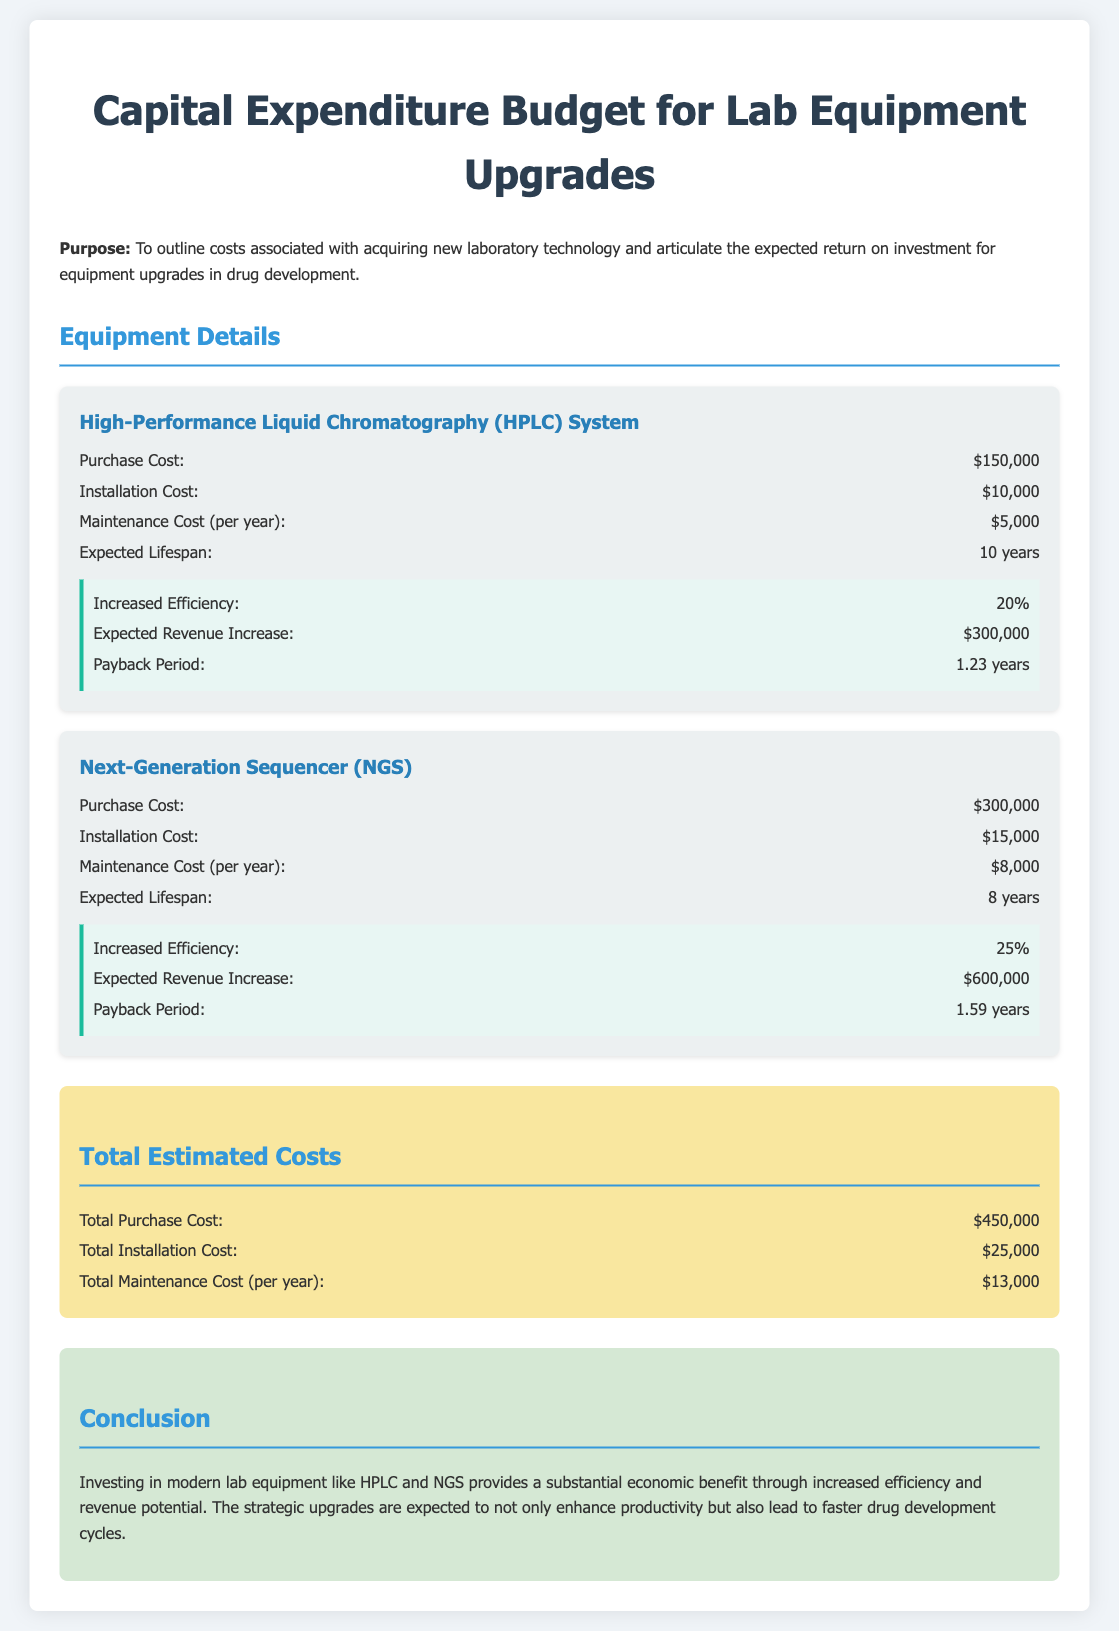What is the purchase cost of the HPLC system? The purchase cost is specifically stated in the document for the HPLC system, which is $150,000.
Answer: $150,000 What is the expected lifespan of the NGS? The expected lifespan of the NGS is mentioned in the document as 8 years.
Answer: 8 years What is the installation cost for both equipment? The total installation cost is calculated from the individual installation costs of HPLC and NGS, which are $10,000 and $15,000 respectively, summing to $25,000.
Answer: $25,000 What is the annual maintenance cost for the HPLC system? The document specifies that the annual maintenance cost for the HPLC system is $5,000.
Answer: $5,000 What is the expected revenue increase from the NGS? The document states the expected revenue increase from the NGS as $600,000.
Answer: $600,000 What is the payback period for the HPLC system? The payback period for the HPLC system is clearly indicated in the document as 1.23 years.
Answer: 1.23 years What percentage increase in efficiency does the NGS provide? The document indicates that the NGS provides an increased efficiency of 25%.
Answer: 25% What is the total estimated maintenance cost per year? The total estimated maintenance cost per year is found by summing the individual maintenance costs from both systems, which totals $13,000.
Answer: $13,000 What is the main conclusion of the document? The conclusion summarizes the benefits and strategic importance of lab equipment upgrades in drug development, emphasizing enhanced productivity and faster cycles.
Answer: Economic benefit 